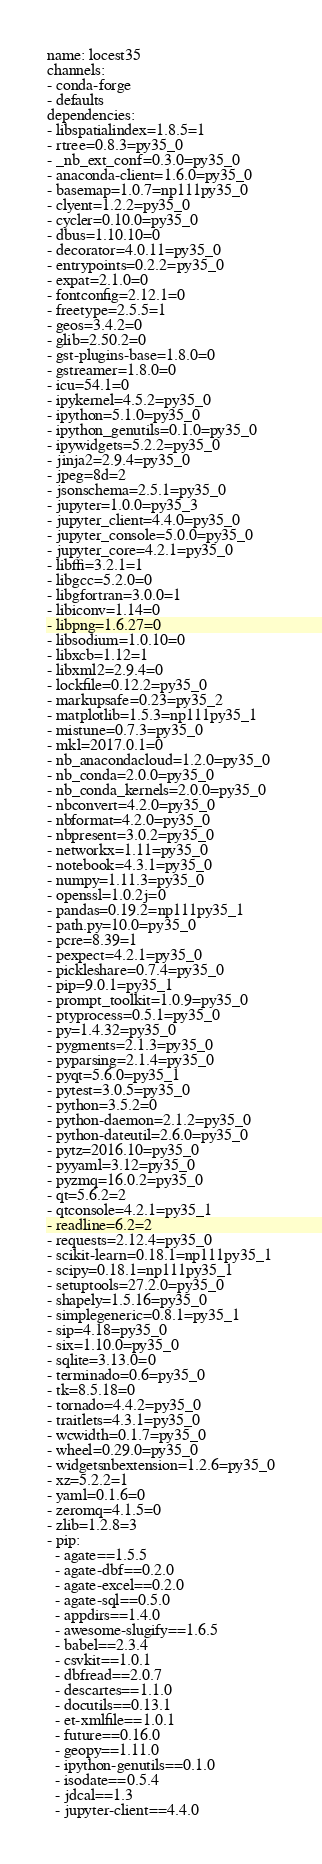Convert code to text. <code><loc_0><loc_0><loc_500><loc_500><_YAML_>name: locest35
channels:
- conda-forge
- defaults
dependencies:
- libspatialindex=1.8.5=1
- rtree=0.8.3=py35_0
- _nb_ext_conf=0.3.0=py35_0
- anaconda-client=1.6.0=py35_0
- basemap=1.0.7=np111py35_0
- clyent=1.2.2=py35_0
- cycler=0.10.0=py35_0
- dbus=1.10.10=0
- decorator=4.0.11=py35_0
- entrypoints=0.2.2=py35_0
- expat=2.1.0=0
- fontconfig=2.12.1=0
- freetype=2.5.5=1
- geos=3.4.2=0
- glib=2.50.2=0
- gst-plugins-base=1.8.0=0
- gstreamer=1.8.0=0
- icu=54.1=0
- ipykernel=4.5.2=py35_0
- ipython=5.1.0=py35_0
- ipython_genutils=0.1.0=py35_0
- ipywidgets=5.2.2=py35_0
- jinja2=2.9.4=py35_0
- jpeg=8d=2
- jsonschema=2.5.1=py35_0
- jupyter=1.0.0=py35_3
- jupyter_client=4.4.0=py35_0
- jupyter_console=5.0.0=py35_0
- jupyter_core=4.2.1=py35_0
- libffi=3.2.1=1
- libgcc=5.2.0=0
- libgfortran=3.0.0=1
- libiconv=1.14=0
- libpng=1.6.27=0
- libsodium=1.0.10=0
- libxcb=1.12=1
- libxml2=2.9.4=0
- lockfile=0.12.2=py35_0
- markupsafe=0.23=py35_2
- matplotlib=1.5.3=np111py35_1
- mistune=0.7.3=py35_0
- mkl=2017.0.1=0
- nb_anacondacloud=1.2.0=py35_0
- nb_conda=2.0.0=py35_0
- nb_conda_kernels=2.0.0=py35_0
- nbconvert=4.2.0=py35_0
- nbformat=4.2.0=py35_0
- nbpresent=3.0.2=py35_0
- networkx=1.11=py35_0
- notebook=4.3.1=py35_0
- numpy=1.11.3=py35_0
- openssl=1.0.2j=0
- pandas=0.19.2=np111py35_1
- path.py=10.0=py35_0
- pcre=8.39=1
- pexpect=4.2.1=py35_0
- pickleshare=0.7.4=py35_0
- pip=9.0.1=py35_1
- prompt_toolkit=1.0.9=py35_0
- ptyprocess=0.5.1=py35_0
- py=1.4.32=py35_0
- pygments=2.1.3=py35_0
- pyparsing=2.1.4=py35_0
- pyqt=5.6.0=py35_1
- pytest=3.0.5=py35_0
- python=3.5.2=0
- python-daemon=2.1.2=py35_0
- python-dateutil=2.6.0=py35_0
- pytz=2016.10=py35_0
- pyyaml=3.12=py35_0
- pyzmq=16.0.2=py35_0
- qt=5.6.2=2
- qtconsole=4.2.1=py35_1
- readline=6.2=2
- requests=2.12.4=py35_0
- scikit-learn=0.18.1=np111py35_1
- scipy=0.18.1=np111py35_1
- setuptools=27.2.0=py35_0
- shapely=1.5.16=py35_0
- simplegeneric=0.8.1=py35_1
- sip=4.18=py35_0
- six=1.10.0=py35_0
- sqlite=3.13.0=0
- terminado=0.6=py35_0
- tk=8.5.18=0
- tornado=4.4.2=py35_0
- traitlets=4.3.1=py35_0
- wcwidth=0.1.7=py35_0
- wheel=0.29.0=py35_0
- widgetsnbextension=1.2.6=py35_0
- xz=5.2.2=1
- yaml=0.1.6=0
- zeromq=4.1.5=0
- zlib=1.2.8=3
- pip:
  - agate==1.5.5
  - agate-dbf==0.2.0
  - agate-excel==0.2.0
  - agate-sql==0.5.0
  - appdirs==1.4.0
  - awesome-slugify==1.6.5
  - babel==2.3.4
  - csvkit==1.0.1
  - dbfread==2.0.7
  - descartes==1.1.0
  - docutils==0.13.1
  - et-xmlfile==1.0.1
  - future==0.16.0
  - geopy==1.11.0
  - ipython-genutils==0.1.0
  - isodate==0.5.4
  - jdcal==1.3
  - jupyter-client==4.4.0</code> 